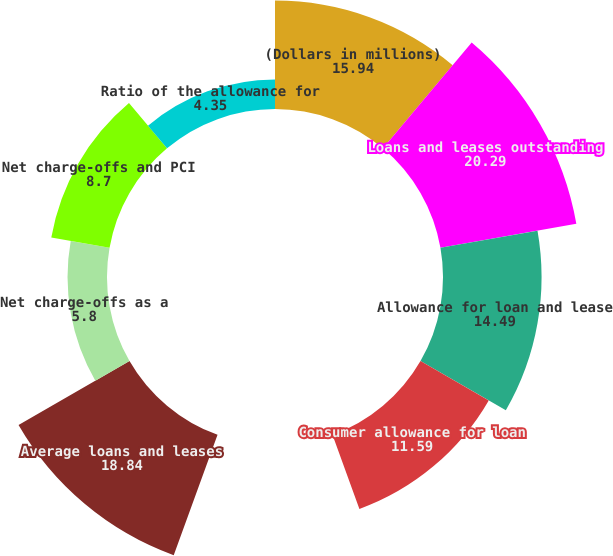<chart> <loc_0><loc_0><loc_500><loc_500><pie_chart><fcel>(Dollars in millions)<fcel>Loans and leases outstanding<fcel>Allowance for loan and lease<fcel>Consumer allowance for loan<fcel>Commercial allowance for loan<fcel>Average loans and leases<fcel>Net charge-offs as a<fcel>Net charge-offs and PCI<fcel>Ratio of the allowance for<nl><fcel>15.94%<fcel>20.29%<fcel>14.49%<fcel>11.59%<fcel>0.0%<fcel>18.84%<fcel>5.8%<fcel>8.7%<fcel>4.35%<nl></chart> 